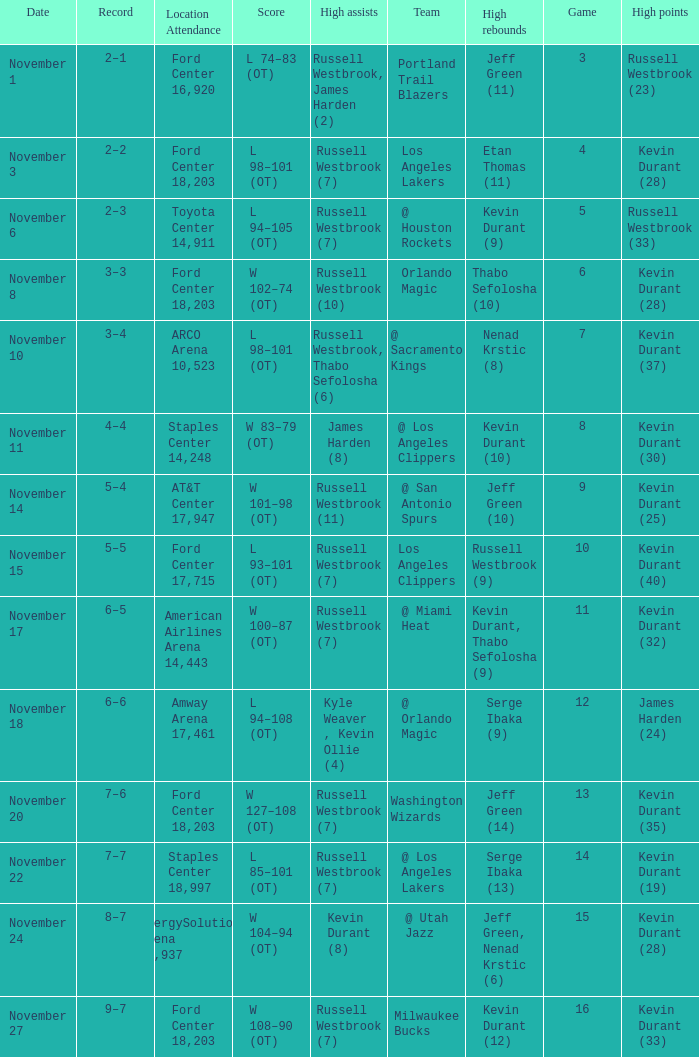What was the record in the game in which Jeff Green (14) did the most high rebounds? 7–6. 